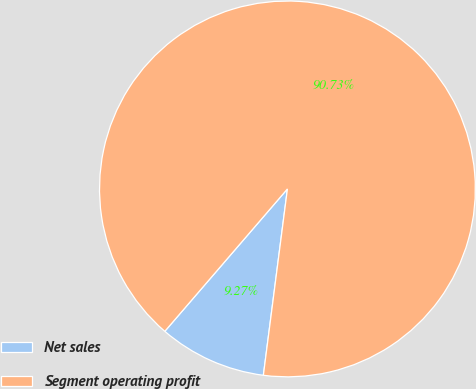<chart> <loc_0><loc_0><loc_500><loc_500><pie_chart><fcel>Net sales<fcel>Segment operating profit<nl><fcel>9.27%<fcel>90.73%<nl></chart> 